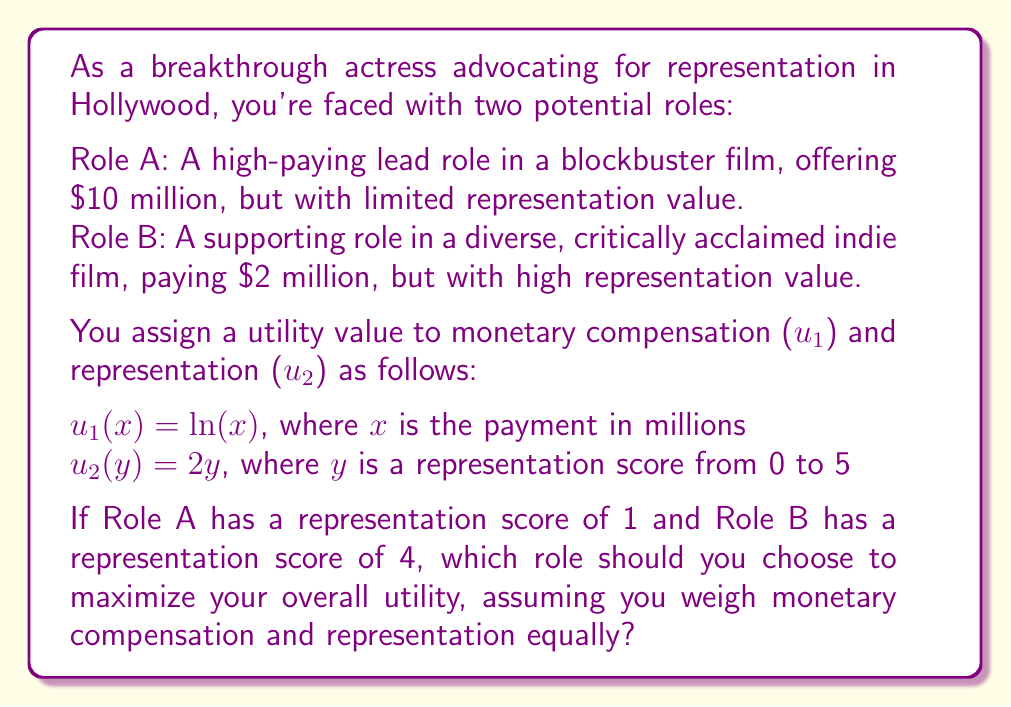Show me your answer to this math problem. To solve this problem, we need to apply utility theory and calculate the total utility for each role. Let's break it down step-by-step:

1. Define the utility functions:
   - For monetary compensation: $u_1(x) = \ln(x)$
   - For representation: $u_2(y) = 2y$

2. Calculate the utilities for Role A:
   - Monetary utility: $u_1(10) = \ln(10) \approx 2.30$
   - Representation utility: $u_2(1) = 2(1) = 2$
   - Total utility for Role A: $U_A = 2.30 + 2 = 4.30$

3. Calculate the utilities for Role B:
   - Monetary utility: $u_1(2) = \ln(2) \approx 0.69$
   - Representation utility: $u_2(4) = 2(4) = 8$
   - Total utility for Role B: $U_B = 0.69 + 8 = 8.69$

4. Compare the total utilities:
   $U_B (8.69) > U_A (4.30)$

Since the total utility for Role B is greater than that of Role A, you should choose Role B to maximize your overall utility.

This decision reflects the trade-off between high-paying roles and roles that advance representation. Despite the significantly lower pay, the high representation value of Role B outweighs the monetary advantage of Role A when considering both factors equally.
Answer: Choose Role B (the supporting role in the diverse indie film) to maximize overall utility. The total utility for Role B (8.69) is higher than the total utility for Role A (4.30). 